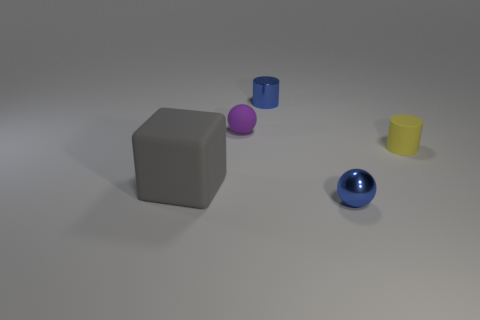What is the shape of the purple thing that is the same size as the blue metallic cylinder?
Offer a terse response. Sphere. Are there more blue metallic cubes than purple matte spheres?
Your response must be concise. No. Is there a matte cube that is behind the matte block that is in front of the tiny yellow cylinder?
Provide a short and direct response. No. What color is the other tiny object that is the same shape as the yellow object?
Your response must be concise. Blue. Are there any other things that have the same shape as the gray object?
Keep it short and to the point. No. What is the color of the big thing that is the same material as the small yellow object?
Provide a short and direct response. Gray. There is a small cylinder on the right side of the metallic thing that is behind the big gray matte object; is there a matte object right of it?
Keep it short and to the point. No. Are there fewer gray cubes that are to the left of the block than tiny cylinders that are behind the yellow rubber object?
Your response must be concise. Yes. What number of things are the same material as the blue cylinder?
Make the answer very short. 1. Do the rubber ball and the ball on the right side of the tiny metal cylinder have the same size?
Your answer should be very brief. Yes. 